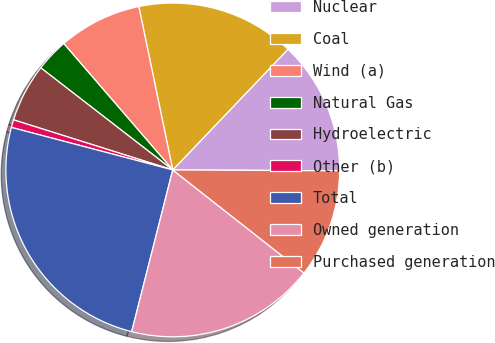Convert chart. <chart><loc_0><loc_0><loc_500><loc_500><pie_chart><fcel>Nuclear<fcel>Coal<fcel>Wind (a)<fcel>Natural Gas<fcel>Hydroelectric<fcel>Other (b)<fcel>Total<fcel>Owned generation<fcel>Purchased generation<nl><fcel>12.95%<fcel>15.39%<fcel>8.07%<fcel>3.19%<fcel>5.63%<fcel>0.75%<fcel>25.14%<fcel>18.36%<fcel>10.51%<nl></chart> 